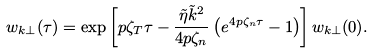Convert formula to latex. <formula><loc_0><loc_0><loc_500><loc_500>w _ { k \perp } ( \tau ) = \exp \left [ p \zeta _ { T } \tau - \frac { \tilde { \eta } \tilde { k } ^ { 2 } } { 4 p \zeta _ { n } } \left ( e ^ { 4 p \zeta _ { n } \tau } - 1 \right ) \right ] w _ { k \perp } ( 0 ) .</formula> 